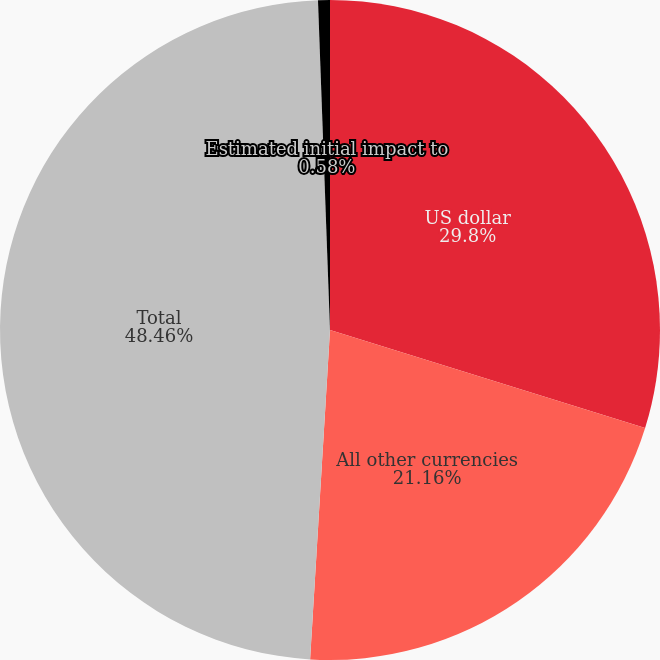Convert chart. <chart><loc_0><loc_0><loc_500><loc_500><pie_chart><fcel>US dollar<fcel>All other currencies<fcel>Total<fcel>Estimated initial impact to<nl><fcel>29.8%<fcel>21.16%<fcel>48.46%<fcel>0.58%<nl></chart> 